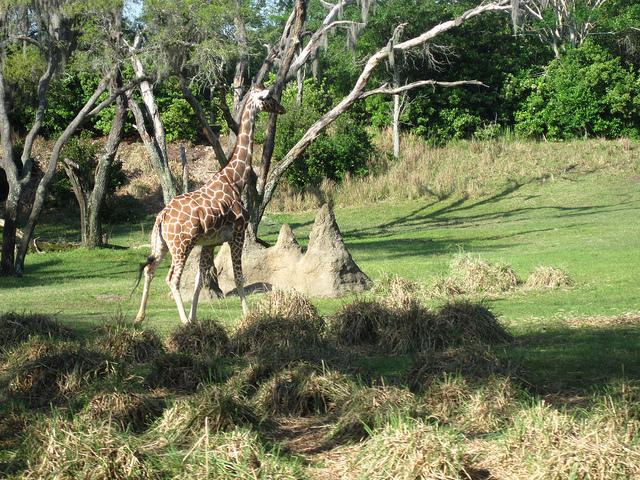Why is there no leaves on that one tree?
Be succinct. Giraffe ate them. How many animals are in this picture?
Answer briefly. 1. What animal is this?
Give a very brief answer. Giraffe. What is the animal standing next to?
Be succinct. Tree. 